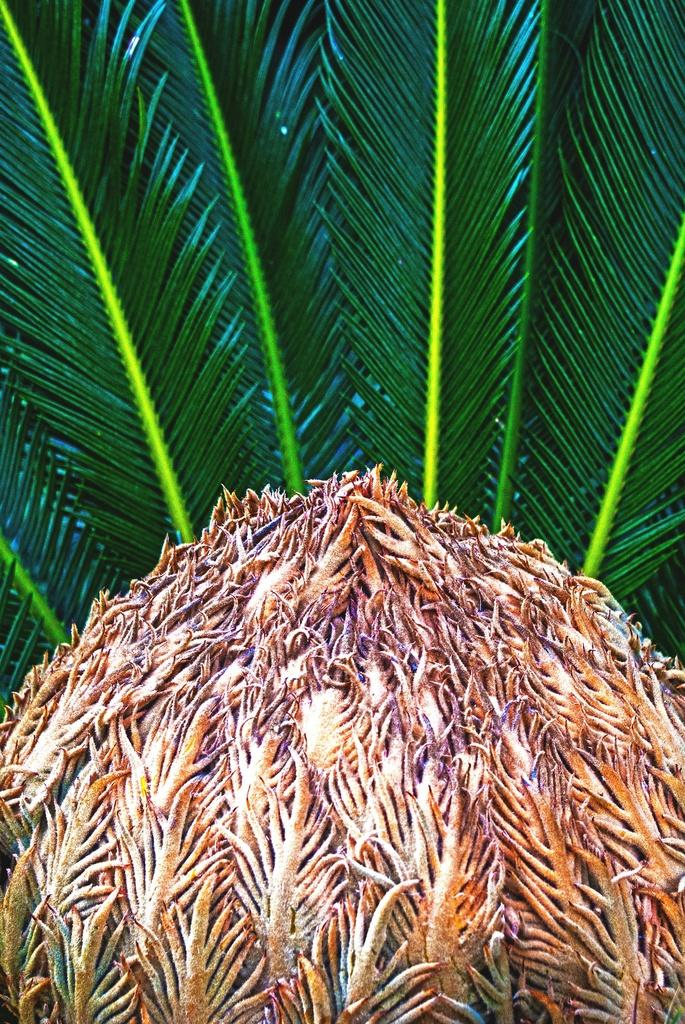What type of vegetation can be seen in the image? There are leaves in the image. What else can be seen at the bottom of the image? There is an object that appears to be a fruit at the bottom of the image. What is the price of the flag in the image? There is no flag present in the image, so it is not possible to determine its price. 